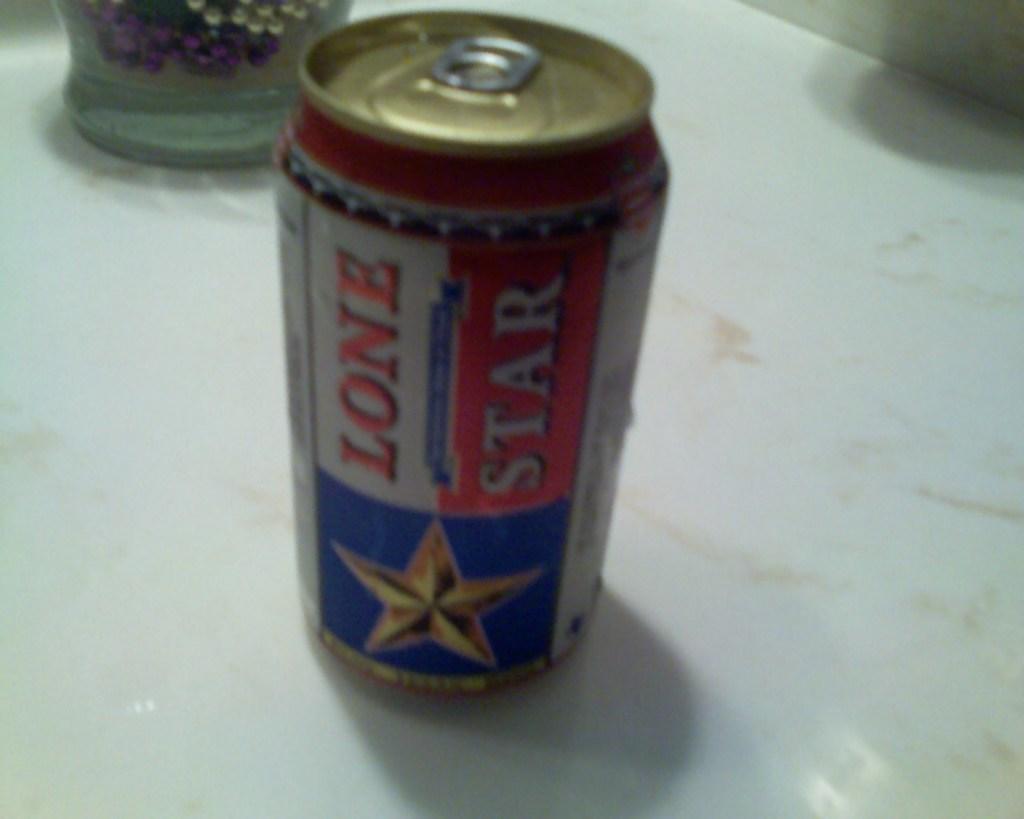Is the word star written in the bottle?
Your response must be concise. Yes. 